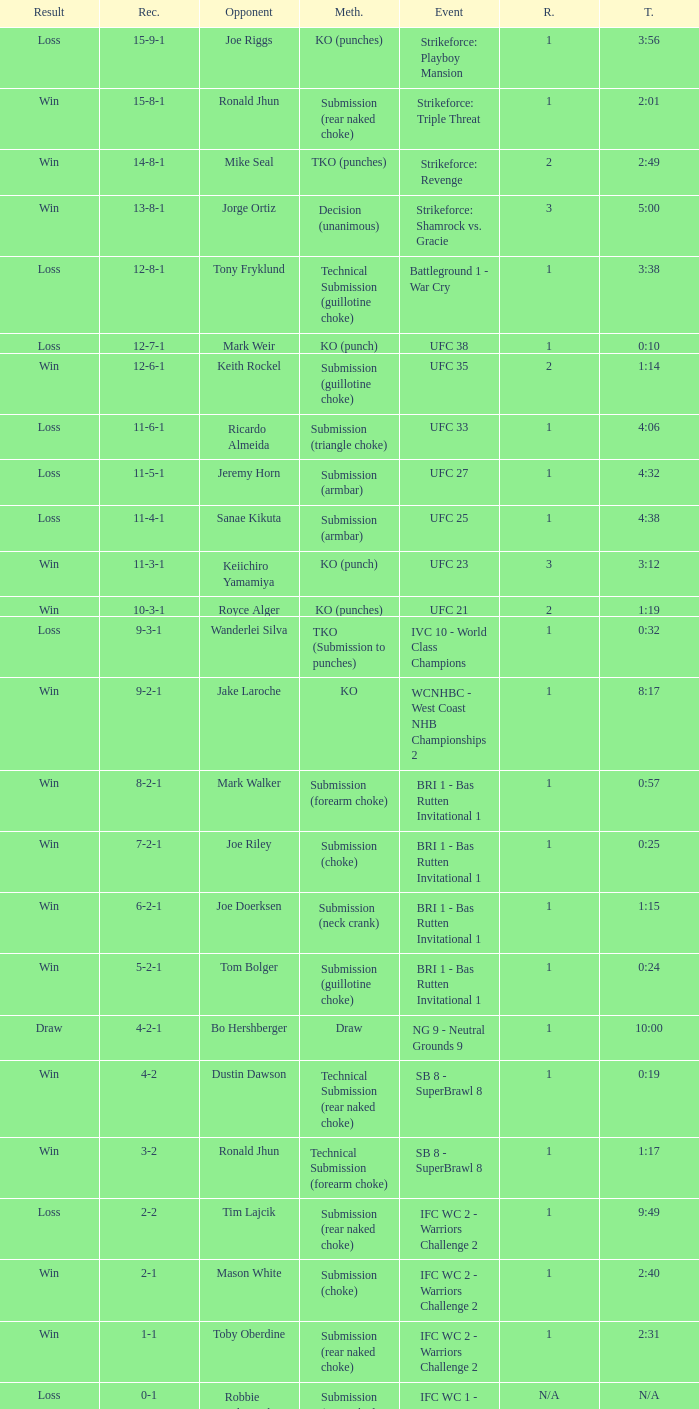During ufc 27, what was the performance record? 11-5-1. 